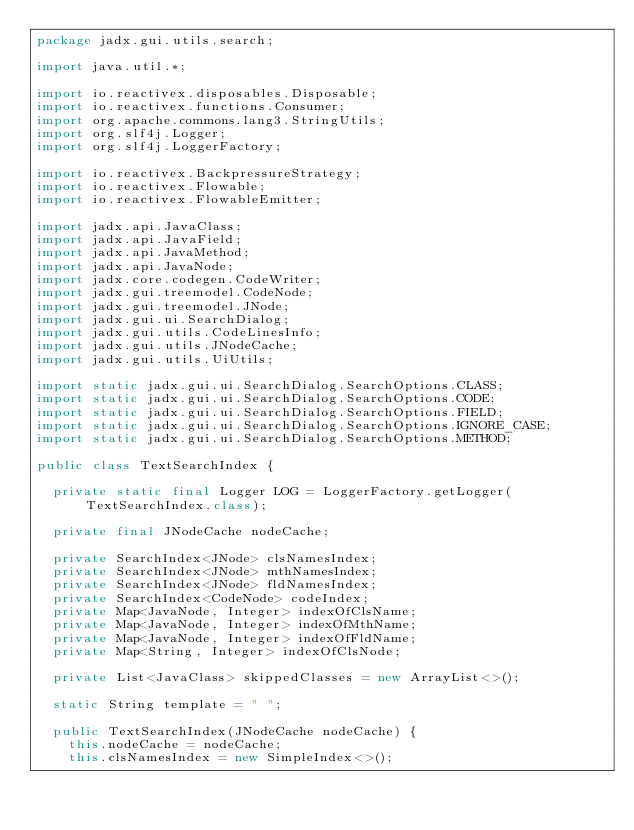<code> <loc_0><loc_0><loc_500><loc_500><_Java_>package jadx.gui.utils.search;

import java.util.*;

import io.reactivex.disposables.Disposable;
import io.reactivex.functions.Consumer;
import org.apache.commons.lang3.StringUtils;
import org.slf4j.Logger;
import org.slf4j.LoggerFactory;

import io.reactivex.BackpressureStrategy;
import io.reactivex.Flowable;
import io.reactivex.FlowableEmitter;

import jadx.api.JavaClass;
import jadx.api.JavaField;
import jadx.api.JavaMethod;
import jadx.api.JavaNode;
import jadx.core.codegen.CodeWriter;
import jadx.gui.treemodel.CodeNode;
import jadx.gui.treemodel.JNode;
import jadx.gui.ui.SearchDialog;
import jadx.gui.utils.CodeLinesInfo;
import jadx.gui.utils.JNodeCache;
import jadx.gui.utils.UiUtils;

import static jadx.gui.ui.SearchDialog.SearchOptions.CLASS;
import static jadx.gui.ui.SearchDialog.SearchOptions.CODE;
import static jadx.gui.ui.SearchDialog.SearchOptions.FIELD;
import static jadx.gui.ui.SearchDialog.SearchOptions.IGNORE_CASE;
import static jadx.gui.ui.SearchDialog.SearchOptions.METHOD;

public class TextSearchIndex {

	private static final Logger LOG = LoggerFactory.getLogger(TextSearchIndex.class);

	private final JNodeCache nodeCache;

	private SearchIndex<JNode> clsNamesIndex;
	private SearchIndex<JNode> mthNamesIndex;
	private SearchIndex<JNode> fldNamesIndex;
	private SearchIndex<CodeNode> codeIndex;
	private Map<JavaNode, Integer> indexOfClsName;
	private Map<JavaNode, Integer> indexOfMthName;
	private Map<JavaNode, Integer> indexOfFldName;
	private Map<String, Integer> indexOfClsNode;

	private List<JavaClass> skippedClasses = new ArrayList<>();

	static String template = " ";

	public TextSearchIndex(JNodeCache nodeCache) {
		this.nodeCache = nodeCache;
		this.clsNamesIndex = new SimpleIndex<>();</code> 